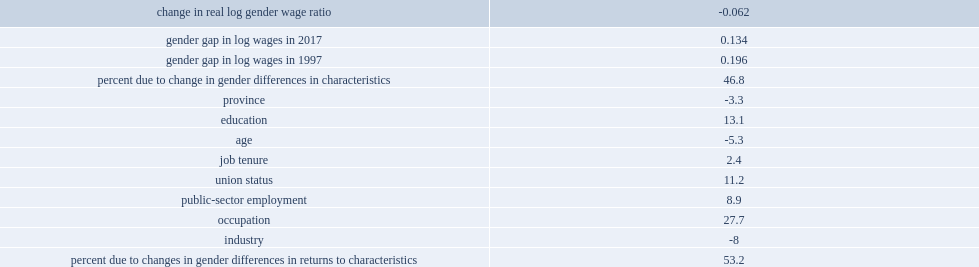What is the percentage of decrease in the gender wage gap that occurred between 1997 and 2017 which was explained by changes in the relative characteristics of women and men? 46.8. Among all the characteristics which explains the change in gender differences, which two were most important? Occupation education. Parse the table in full. {'header': ['change in real log gender wage ratio', '-0.062'], 'rows': [['gender gap in log wages in 2017', '0.134'], ['gender gap in log wages in 1997', '0.196'], ['percent due to change in gender differences in characteristics', '46.8'], ['province', '-3.3'], ['education', '13.1'], ['age', '-5.3'], ['job tenure', '2.4'], ['union status', '11.2'], ['public-sector employment', '8.9'], ['occupation', '27.7'], ['industry', '-8'], ['percent due to changes in gender differences in returns to characteristics', '53.2']]} 